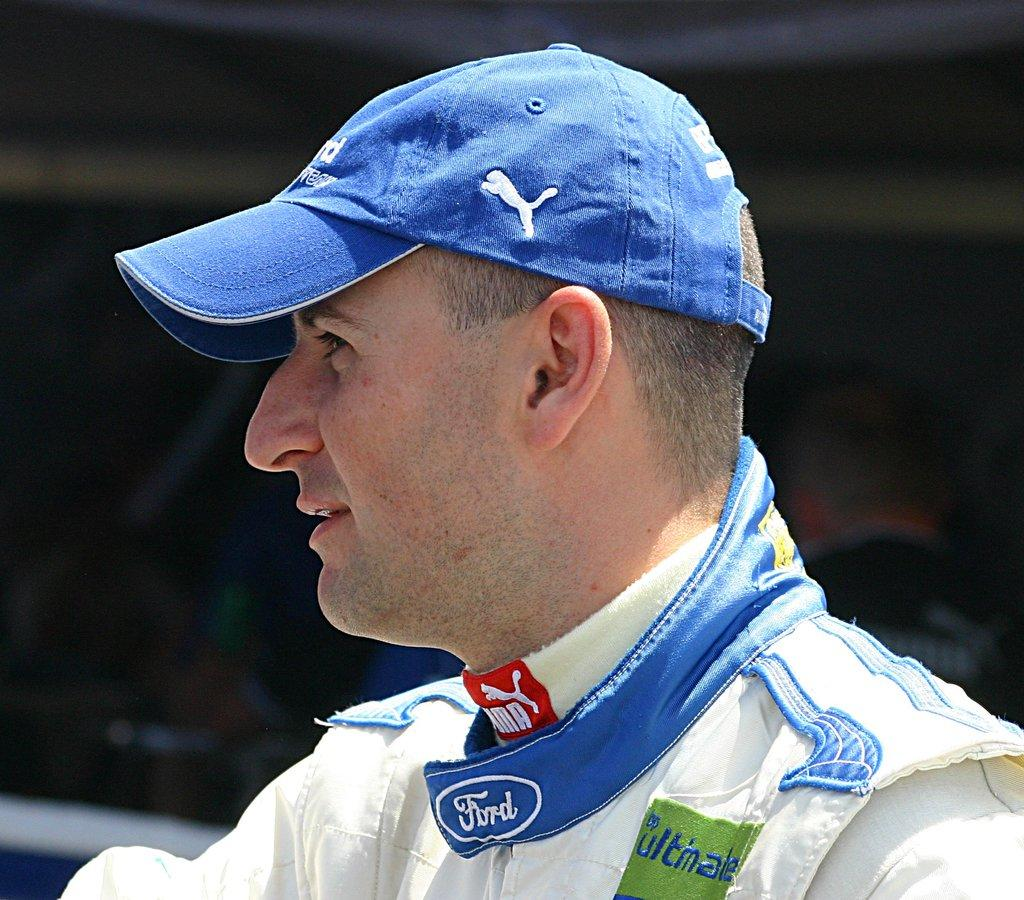Who is present in the image? There is a man in the image. What is the man wearing on his head? The man is wearing a cap. Can you describe the background of the image? The background of the image is blurry. What type of game is the man playing in the image? There is no game present in the image; it only features a man wearing a cap with a blurry background. 